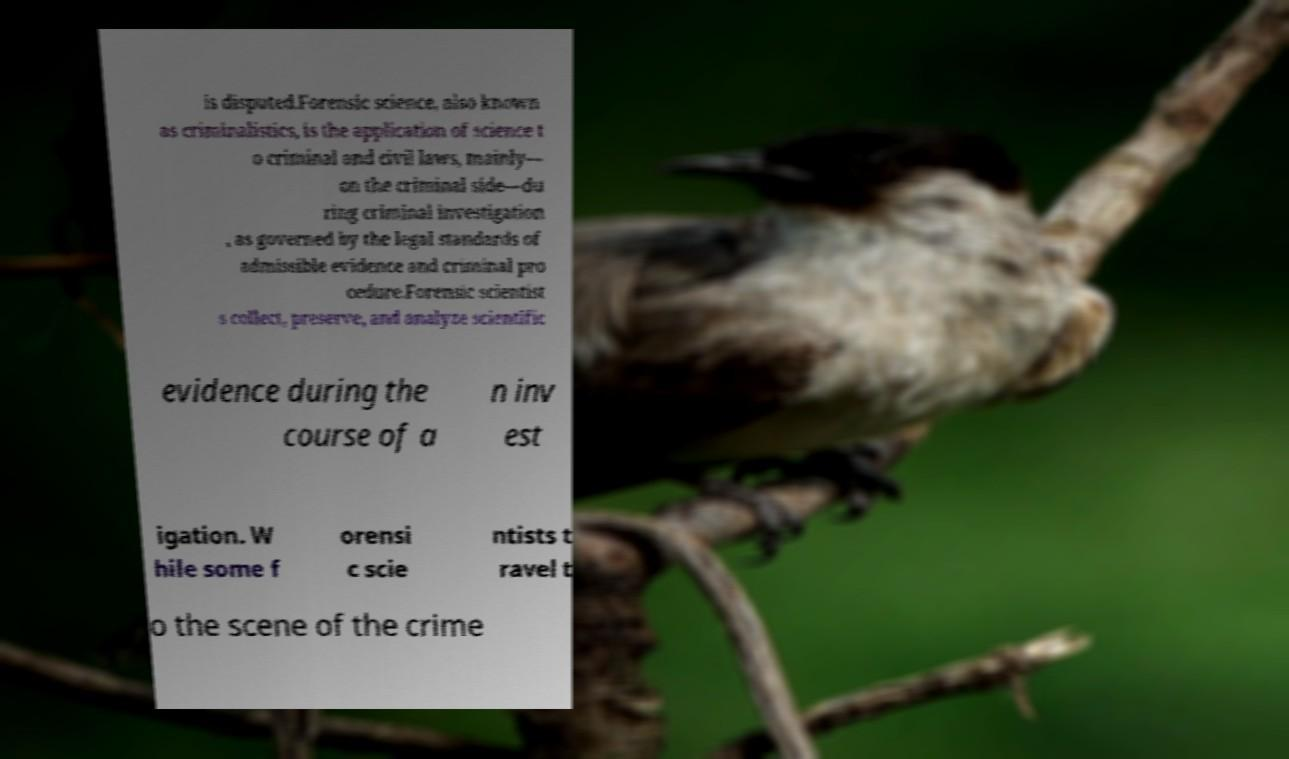Could you extract and type out the text from this image? is disputed.Forensic science, also known as criminalistics, is the application of science t o criminal and civil laws, mainly— on the criminal side—du ring criminal investigation , as governed by the legal standards of admissible evidence and criminal pro cedure.Forensic scientist s collect, preserve, and analyze scientific evidence during the course of a n inv est igation. W hile some f orensi c scie ntists t ravel t o the scene of the crime 